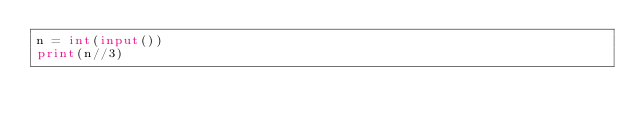Convert code to text. <code><loc_0><loc_0><loc_500><loc_500><_Python_>n = int(input())
print(n//3)</code> 